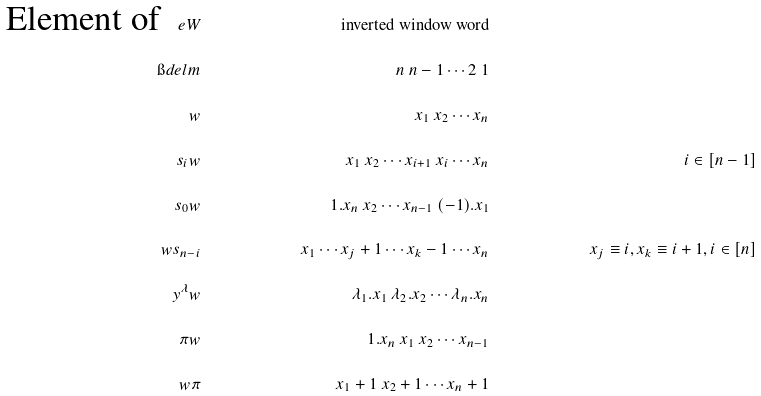<formula> <loc_0><loc_0><loc_500><loc_500>\quad \text {Element of } \ e W & & \text {inverted window word} & & \\ \i d e l m & & n \ n - 1 \cdots 2 \ 1 & & \\ w & & x _ { 1 } \ x _ { 2 } \cdots x _ { n } & & \\ s _ { i } w & & x _ { 1 } \ x _ { 2 } \cdots x _ { i + 1 } \ x _ { i } \cdots x _ { n } & & i \in [ n - 1 ] \\ s _ { 0 } w & & 1 . x _ { n } \ x _ { 2 } \cdots x _ { n - 1 } \ ( - 1 ) . x _ { 1 } & & \\ w s _ { n - i } & & x _ { 1 } \cdots x _ { j } + 1 \cdots x _ { k } - 1 \cdots x _ { n } & & x _ { j } \equiv i , x _ { k } \equiv i + 1 , i \in [ n ] \\ y ^ { \lambda } w & & \lambda _ { 1 } . x _ { 1 } \ \lambda _ { 2 } . x _ { 2 } \cdots \lambda _ { n } . x _ { n } & & \\ \pi w & & 1 . x _ { n } \ x _ { 1 } \ x _ { 2 } \cdots x _ { n - 1 } & & \\ w \pi & & x _ { 1 } + 1 \ x _ { 2 } + 1 \cdots x _ { n } + 1</formula> 